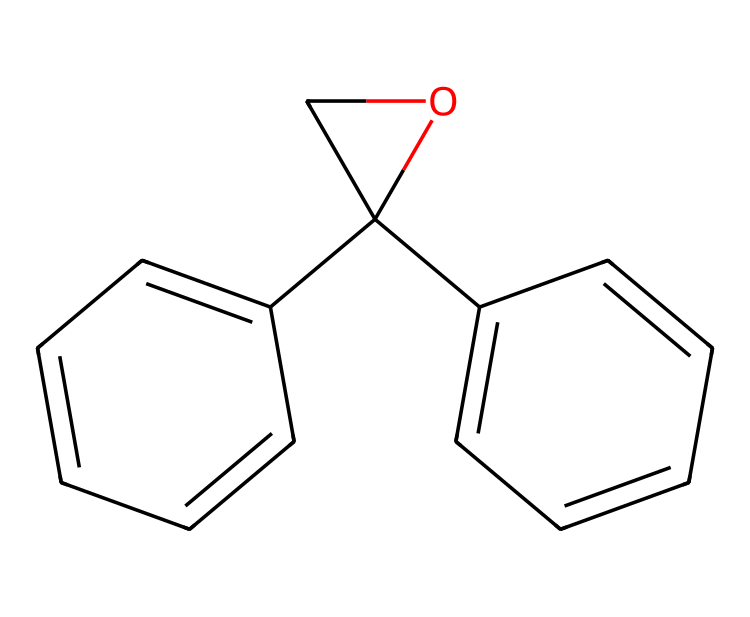how many carbon atoms are in this chemical? By analyzing the SMILES representation, we count the number of carbon (C) atoms present. The given SMILES contains several 'C's that indicate carbon atoms, and there are a total of 15 occurrences of 'C'.
Answer: 15 what is the main functional group present in this chemical? The structure from the SMILES suggests the presence of multiple aromatic rings and a hydroxyl group. The presence of the hydroxyl (-OH) indicates that this chemical has an alcohol functional group.
Answer: alcohol how many rings are in this chemical structure? Looking closely at the molecular structure depicted by the SMILES, we can see that there are three ring structures. This is evident from the notation that indicates cyclic chains with 'C's branch to form rings.
Answer: 3 does this chemical contain any double bonds? The presence of the '=' sign in the SMILES indicates double bonds between carbon atoms. By reviewing the structure for such notations, we find that there are indeed multiple double bonds in the compound.
Answer: yes is this compound likely to be hazardous when used in construction? Given that the structure indicates the presence of epoxy resins, which are known to be effective adhesives but can contain hazardous components, it poses potential risks. Additionally, safety data sheets provide further insights into the specific hazards related to the chemical.
Answer: yes what kind of adhesive properties does this chemical possess? Based on the presence of epoxy groups in the molecular structure, we can deduce that this compound is likely to exhibit strong bonding capabilities, making it effective as an adhesive. Epoxy resins are known for their excellent adhesion to various substrates including metals and plastics.
Answer: strong adhesion 